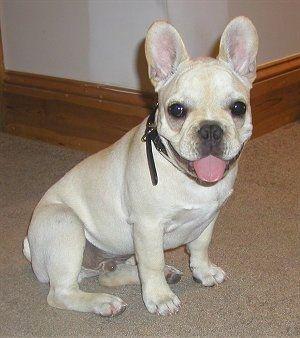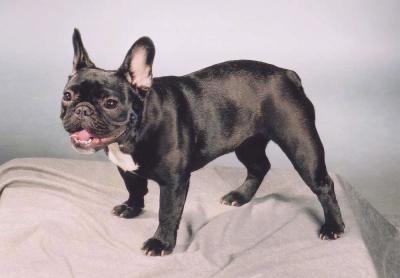The first image is the image on the left, the second image is the image on the right. Evaluate the accuracy of this statement regarding the images: "There are at least three dogs.". Is it true? Answer yes or no. No. The first image is the image on the left, the second image is the image on the right. Given the left and right images, does the statement "One image contains a single light-colored dog, and the other includes a black dog standing on all fours." hold true? Answer yes or no. Yes. 